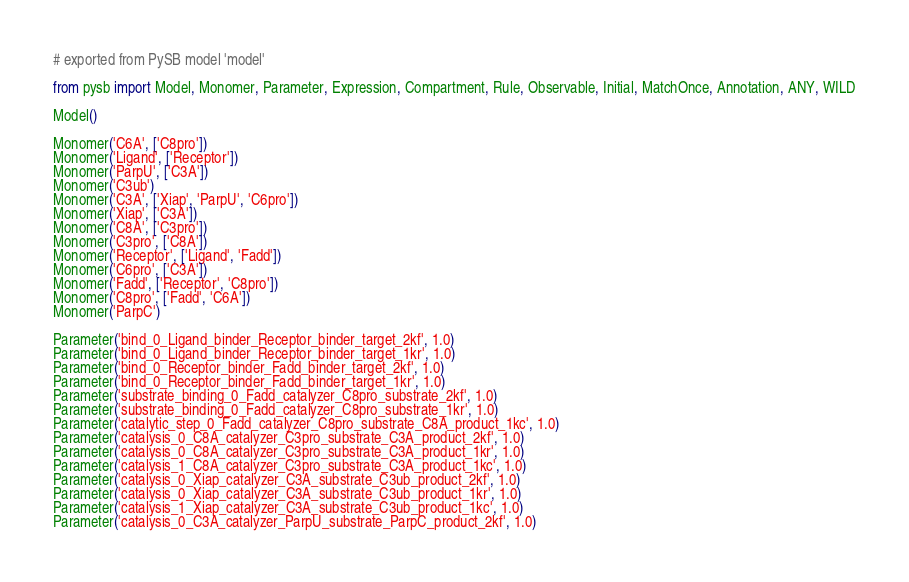<code> <loc_0><loc_0><loc_500><loc_500><_Python_># exported from PySB model 'model'

from pysb import Model, Monomer, Parameter, Expression, Compartment, Rule, Observable, Initial, MatchOnce, Annotation, ANY, WILD

Model()

Monomer('C6A', ['C8pro'])
Monomer('Ligand', ['Receptor'])
Monomer('ParpU', ['C3A'])
Monomer('C3ub')
Monomer('C3A', ['Xiap', 'ParpU', 'C6pro'])
Monomer('Xiap', ['C3A'])
Monomer('C8A', ['C3pro'])
Monomer('C3pro', ['C8A'])
Monomer('Receptor', ['Ligand', 'Fadd'])
Monomer('C6pro', ['C3A'])
Monomer('Fadd', ['Receptor', 'C8pro'])
Monomer('C8pro', ['Fadd', 'C6A'])
Monomer('ParpC')

Parameter('bind_0_Ligand_binder_Receptor_binder_target_2kf', 1.0)
Parameter('bind_0_Ligand_binder_Receptor_binder_target_1kr', 1.0)
Parameter('bind_0_Receptor_binder_Fadd_binder_target_2kf', 1.0)
Parameter('bind_0_Receptor_binder_Fadd_binder_target_1kr', 1.0)
Parameter('substrate_binding_0_Fadd_catalyzer_C8pro_substrate_2kf', 1.0)
Parameter('substrate_binding_0_Fadd_catalyzer_C8pro_substrate_1kr', 1.0)
Parameter('catalytic_step_0_Fadd_catalyzer_C8pro_substrate_C8A_product_1kc', 1.0)
Parameter('catalysis_0_C8A_catalyzer_C3pro_substrate_C3A_product_2kf', 1.0)
Parameter('catalysis_0_C8A_catalyzer_C3pro_substrate_C3A_product_1kr', 1.0)
Parameter('catalysis_1_C8A_catalyzer_C3pro_substrate_C3A_product_1kc', 1.0)
Parameter('catalysis_0_Xiap_catalyzer_C3A_substrate_C3ub_product_2kf', 1.0)
Parameter('catalysis_0_Xiap_catalyzer_C3A_substrate_C3ub_product_1kr', 1.0)
Parameter('catalysis_1_Xiap_catalyzer_C3A_substrate_C3ub_product_1kc', 1.0)
Parameter('catalysis_0_C3A_catalyzer_ParpU_substrate_ParpC_product_2kf', 1.0)</code> 